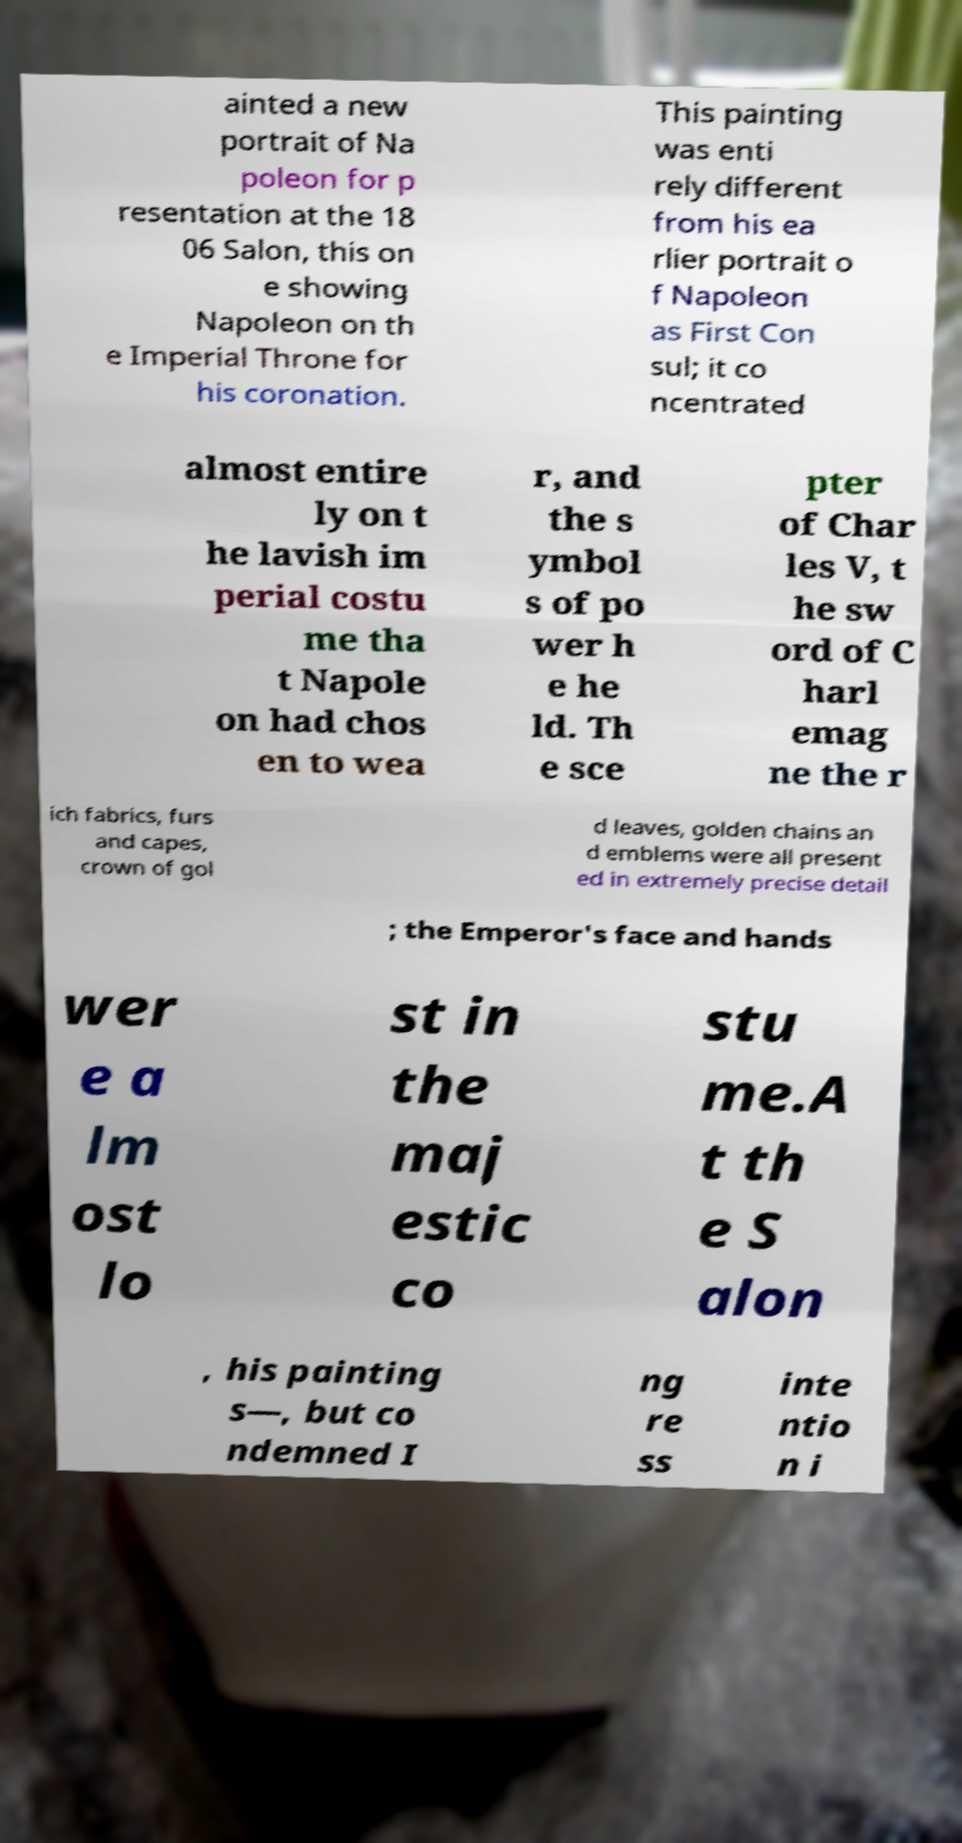Please read and relay the text visible in this image. What does it say? ainted a new portrait of Na poleon for p resentation at the 18 06 Salon, this on e showing Napoleon on th e Imperial Throne for his coronation. This painting was enti rely different from his ea rlier portrait o f Napoleon as First Con sul; it co ncentrated almost entire ly on t he lavish im perial costu me tha t Napole on had chos en to wea r, and the s ymbol s of po wer h e he ld. Th e sce pter of Char les V, t he sw ord of C harl emag ne the r ich fabrics, furs and capes, crown of gol d leaves, golden chains an d emblems were all present ed in extremely precise detail ; the Emperor's face and hands wer e a lm ost lo st in the maj estic co stu me.A t th e S alon , his painting s—, but co ndemned I ng re ss inte ntio n i 